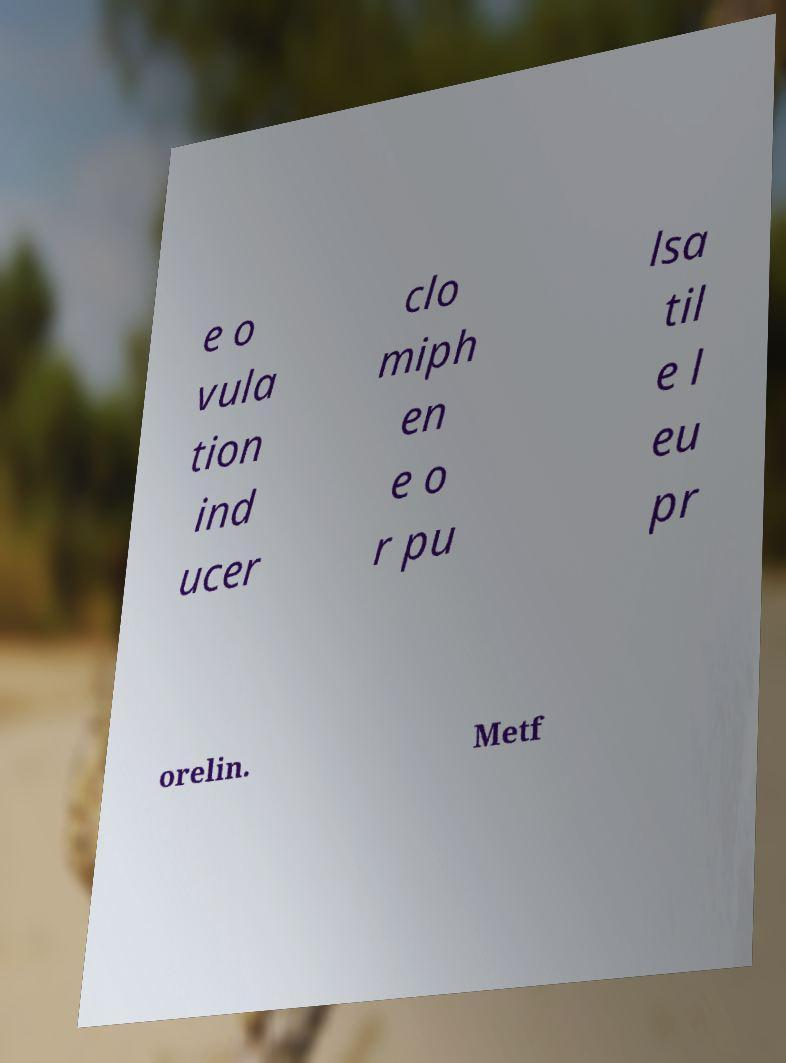I need the written content from this picture converted into text. Can you do that? e o vula tion ind ucer clo miph en e o r pu lsa til e l eu pr orelin. Metf 